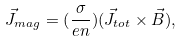Convert formula to latex. <formula><loc_0><loc_0><loc_500><loc_500>\vec { J } _ { m a g } = ( \frac { \sigma } { e n } ) ( \vec { J } _ { t o t } \times \vec { B } ) ,</formula> 